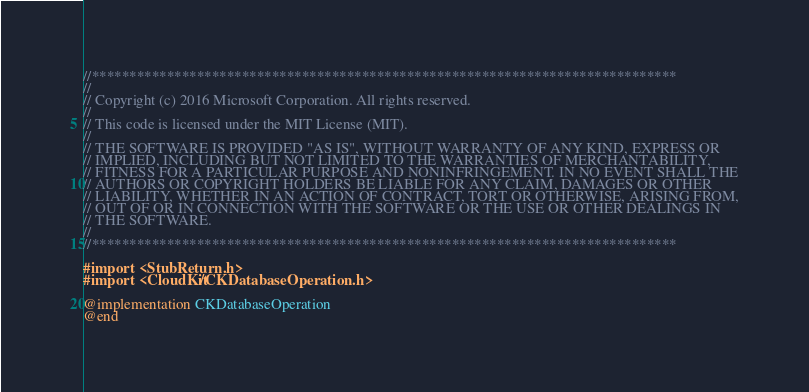<code> <loc_0><loc_0><loc_500><loc_500><_ObjectiveC_>//******************************************************************************
//
// Copyright (c) 2016 Microsoft Corporation. All rights reserved.
//
// This code is licensed under the MIT License (MIT).
//
// THE SOFTWARE IS PROVIDED "AS IS", WITHOUT WARRANTY OF ANY KIND, EXPRESS OR
// IMPLIED, INCLUDING BUT NOT LIMITED TO THE WARRANTIES OF MERCHANTABILITY,
// FITNESS FOR A PARTICULAR PURPOSE AND NONINFRINGEMENT. IN NO EVENT SHALL THE
// AUTHORS OR COPYRIGHT HOLDERS BE LIABLE FOR ANY CLAIM, DAMAGES OR OTHER
// LIABILITY, WHETHER IN AN ACTION OF CONTRACT, TORT OR OTHERWISE, ARISING FROM,
// OUT OF OR IN CONNECTION WITH THE SOFTWARE OR THE USE OR OTHER DEALINGS IN
// THE SOFTWARE.
//
//******************************************************************************

#import <StubReturn.h>
#import <CloudKit/CKDatabaseOperation.h>

@implementation CKDatabaseOperation
@end
</code> 